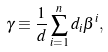Convert formula to latex. <formula><loc_0><loc_0><loc_500><loc_500>\gamma \equiv \frac { 1 } { d } \sum _ { i = 1 } ^ { n } d _ { i } \beta ^ { i } ,</formula> 